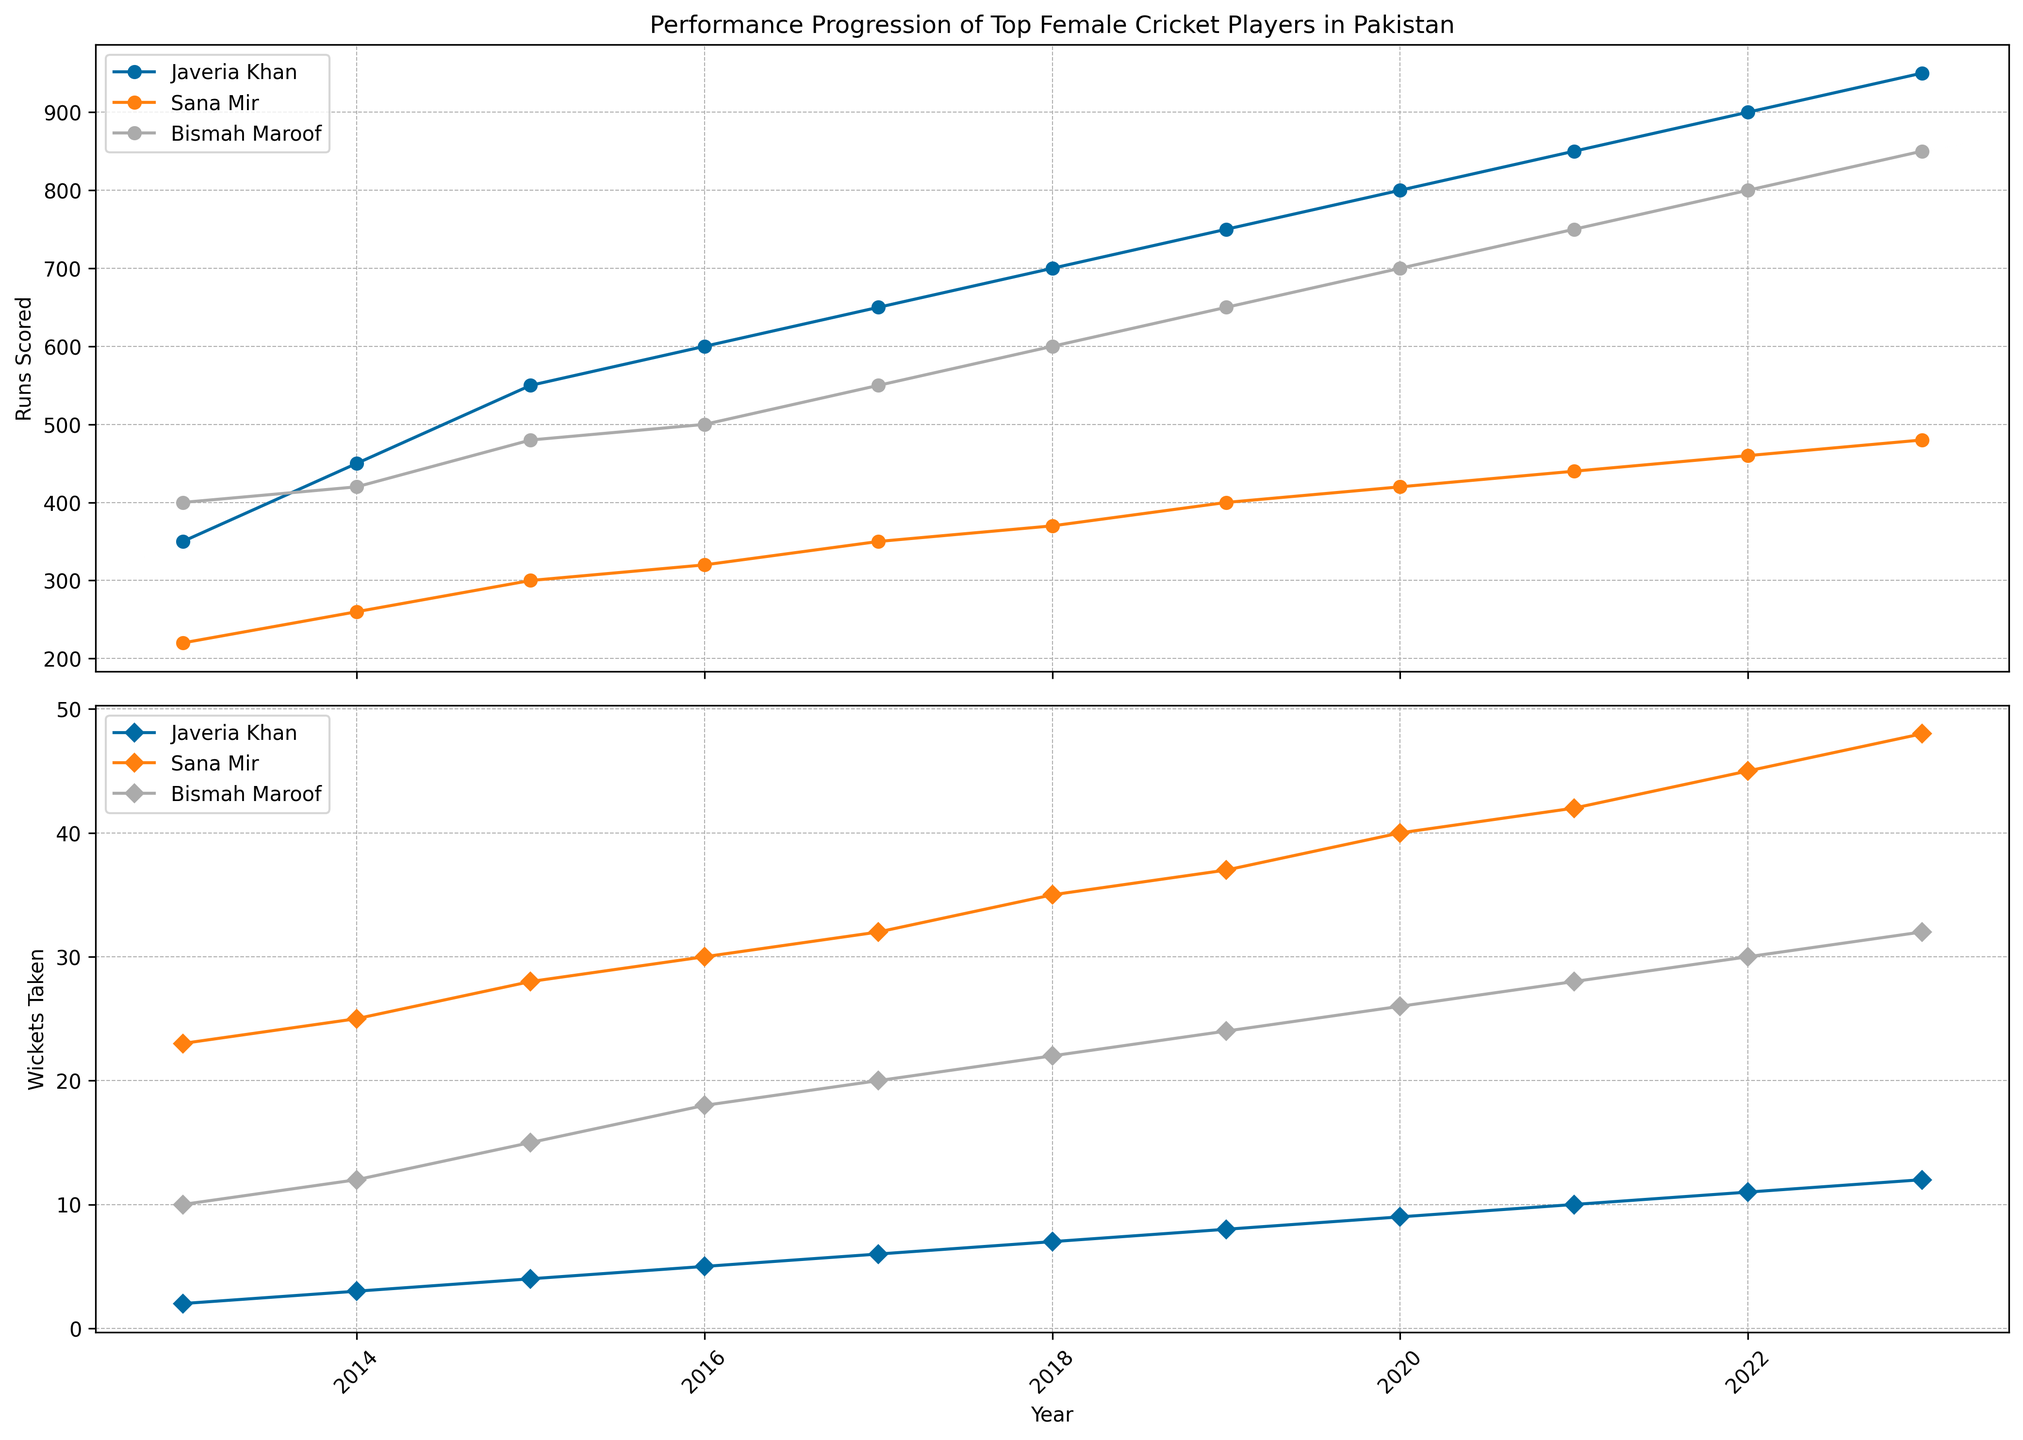Which player scored the most runs in 2023? Look at the plot for "Runs Scored" in 2023. Compare the values for Javeria Khan, Sana Mir, and Bismah Maroof. The highest line will represent the player with the most runs.
Answer: Javeria Khan Who had the highest number of wickets taken in 2020? Look at the plot for "Wickets Taken" in 2020. Compare the values for Javeria Khan, Sana Mir, and Bismah Maroof. The highest line will indicate the player with the most wickets.
Answer: Sana Mir Which player has the steepest increase in runs scored between 2019 and 2020? Observe the slopes of the lines in the "Runs Scored" plot between 2019 and 2020. Identify the player whose line has the steepest upward slope.
Answer: Javeria Khan Compare Sana Mir's and Bismah Maroof's total wickets taken in 2017. Who has taken more wickets? Check the "Wickets Taken" plot for 2017. Compare the values for Sana Mir and Bismah Maroof. The value that is higher indicates who has taken more wickets.
Answer: Sana Mir How much did Javeria Khan's runs scored increase from 2015 to 2016? Look at the "Runs Scored" plot for Javeria Khan in 2015 and 2016. Subtract the 2015 value from the 2016 value.
Answer: 50 Which year did Bismah Maroof first score 600 runs or more? Follow Bismah Maroof's line in the "Runs Scored" plot, identify the first year when it crosses or reaches 600 runs.
Answer: 2018 What is the average number of wickets taken by Sana Mir over the 10 years? Sum all the wickets taken by Sana Mir from 2013 to 2023 and divide by the number of years (10).
Answer: 33 Who had a more consistent performance in terms of runs scored from 2013 to 2023, Sana Mir or Javeria Khan? Compare the "Runs Scored" plot lines for both players. The player whose line shows less fluctuation over the years is more consistent.
Answer: Javeria Khan In which year did Bismah Maroof have her highest runs scored, and how many runs were scored? Look at the peak of Bismah Maroof's line in the "Runs Scored" plot and identify the corresponding year. The peak value indicates the highest runs scored.
Answer: 2023, 850 Calculate the average increase in runs scored per year for Javeria Khan from 2013 to 2023. Find the total increase in runs scored by Javeria Khan from 2013 to 2023 and divide by the number of years (10). (950 - 350) / 10 = 60
Answer: 60 